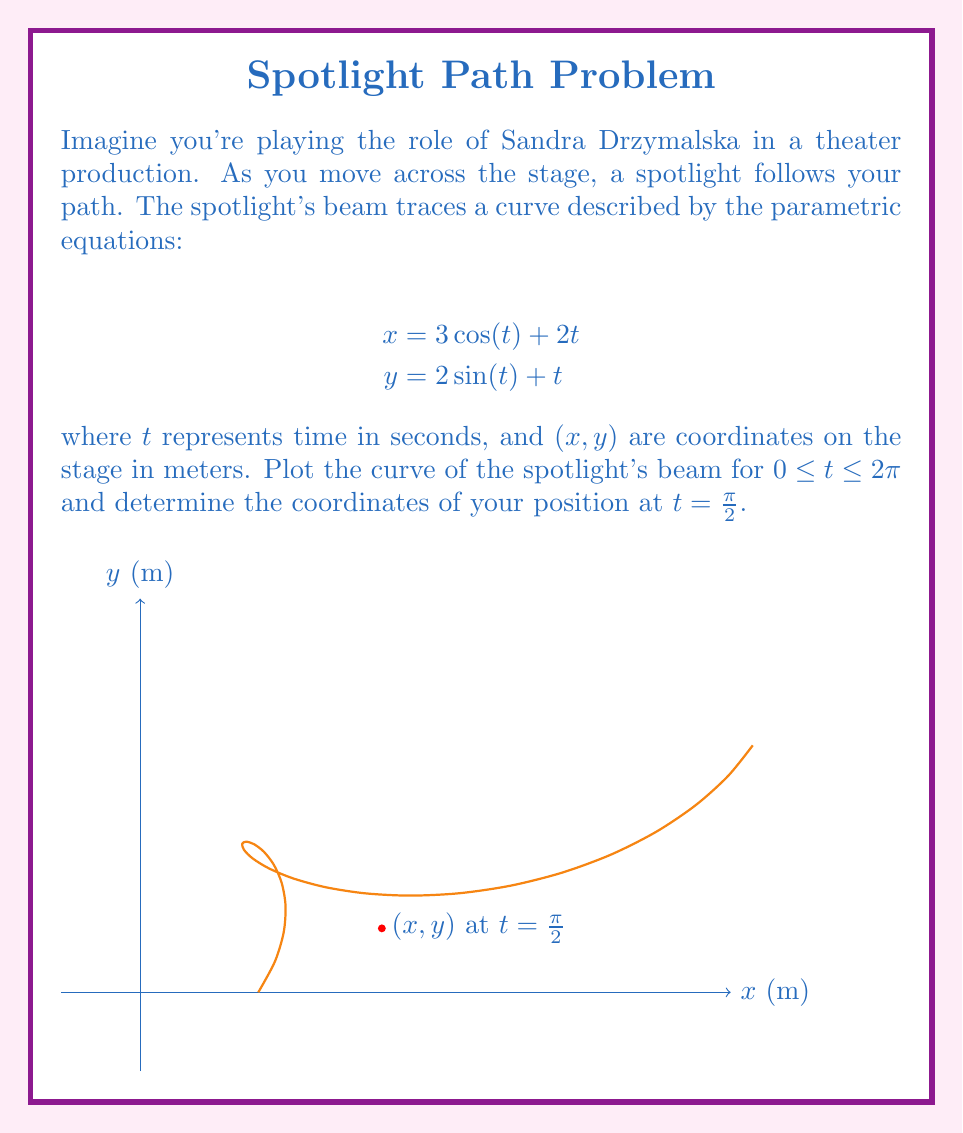Teach me how to tackle this problem. To solve this problem, we'll follow these steps:

1) First, let's plot the curve using the given parametric equations:
   $$x = 3\cos(t) + 2t$$
   $$y = 2\sin(t) + t$$
   for $0 \leq t \leq 2\pi$

   This is shown in the blue curve in the graph above.

2) To find your position at $t = \frac{\pi}{2}$, we need to substitute this value into both equations:

   For x-coordinate:
   $$x = 3\cos(\frac{\pi}{2}) + 2(\frac{\pi}{2})$$
   $$x = 3(0) + \pi = \pi$$

   For y-coordinate:
   $$y = 2\sin(\frac{\pi}{2}) + \frac{\pi}{2}$$
   $$y = 2(1) + \frac{\pi}{2} = 2 + \frac{\pi}{2}$$

3) Therefore, at $t = \frac{\pi}{2}$, your position (marked by the red dot on the graph) is:
   $$(\pi, 2 + \frac{\pi}{2})$$

This point represents where you, playing Sandra Drzymalska, would be on the stage when $t = \frac{\pi}{2}$ seconds have elapsed in your movement across the stage.
Answer: $(\pi, 2 + \frac{\pi}{2})$ 